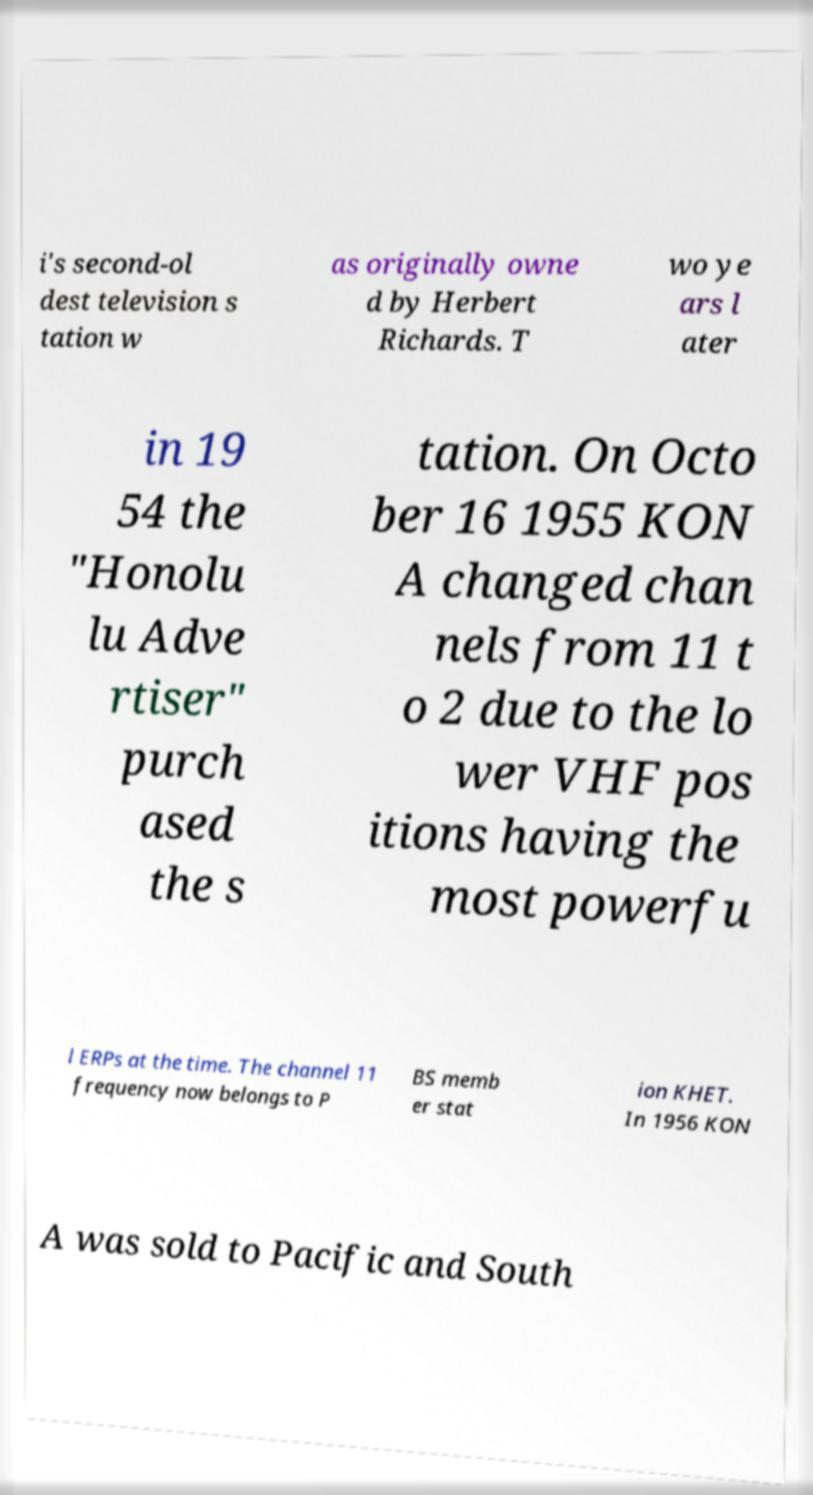Could you assist in decoding the text presented in this image and type it out clearly? i's second-ol dest television s tation w as originally owne d by Herbert Richards. T wo ye ars l ater in 19 54 the "Honolu lu Adve rtiser" purch ased the s tation. On Octo ber 16 1955 KON A changed chan nels from 11 t o 2 due to the lo wer VHF pos itions having the most powerfu l ERPs at the time. The channel 11 frequency now belongs to P BS memb er stat ion KHET. In 1956 KON A was sold to Pacific and South 